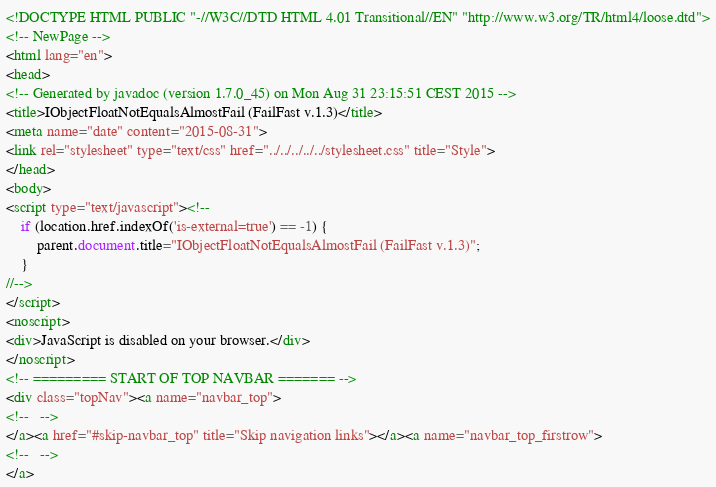<code> <loc_0><loc_0><loc_500><loc_500><_HTML_><!DOCTYPE HTML PUBLIC "-//W3C//DTD HTML 4.01 Transitional//EN" "http://www.w3.org/TR/html4/loose.dtd">
<!-- NewPage -->
<html lang="en">
<head>
<!-- Generated by javadoc (version 1.7.0_45) on Mon Aug 31 23:15:51 CEST 2015 -->
<title>IObjectFloatNotEqualsAlmostFail (FailFast v.1.3)</title>
<meta name="date" content="2015-08-31">
<link rel="stylesheet" type="text/css" href="../../../../../stylesheet.css" title="Style">
</head>
<body>
<script type="text/javascript"><!--
    if (location.href.indexOf('is-external=true') == -1) {
        parent.document.title="IObjectFloatNotEqualsAlmostFail (FailFast v.1.3)";
    }
//-->
</script>
<noscript>
<div>JavaScript is disabled on your browser.</div>
</noscript>
<!-- ========= START OF TOP NAVBAR ======= -->
<div class="topNav"><a name="navbar_top">
<!--   -->
</a><a href="#skip-navbar_top" title="Skip navigation links"></a><a name="navbar_top_firstrow">
<!--   -->
</a></code> 